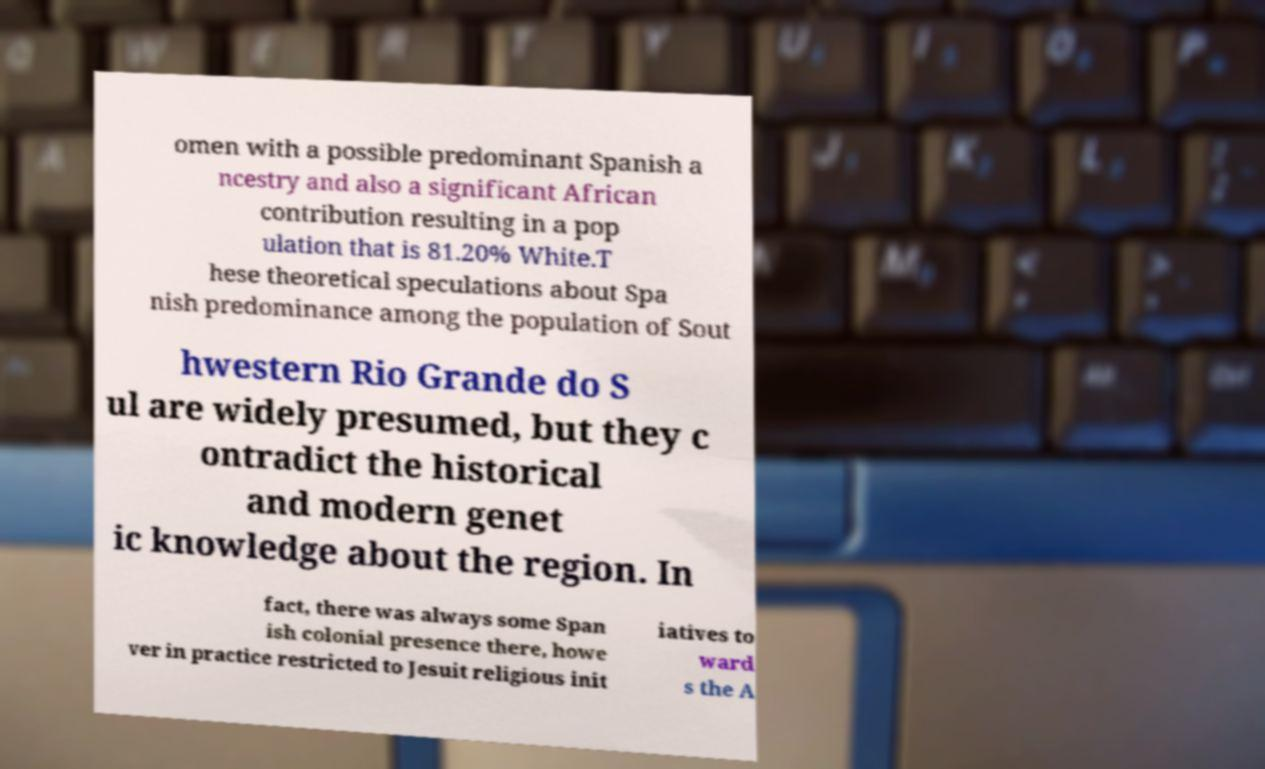There's text embedded in this image that I need extracted. Can you transcribe it verbatim? omen with a possible predominant Spanish a ncestry and also a significant African contribution resulting in a pop ulation that is 81.20% White.T hese theoretical speculations about Spa nish predominance among the population of Sout hwestern Rio Grande do S ul are widely presumed, but they c ontradict the historical and modern genet ic knowledge about the region. In fact, there was always some Span ish colonial presence there, howe ver in practice restricted to Jesuit religious init iatives to ward s the A 